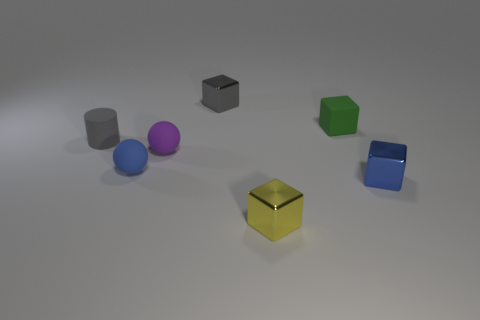Subtract all gray cubes. How many cubes are left? 3 Add 2 small gray cylinders. How many objects exist? 9 Subtract all cubes. How many objects are left? 3 Subtract all blue cubes. How many cubes are left? 3 Add 6 brown balls. How many brown balls exist? 6 Subtract 0 green balls. How many objects are left? 7 Subtract all cyan cubes. Subtract all cyan spheres. How many cubes are left? 4 Subtract all small metal blocks. Subtract all tiny green rubber things. How many objects are left? 3 Add 1 gray blocks. How many gray blocks are left? 2 